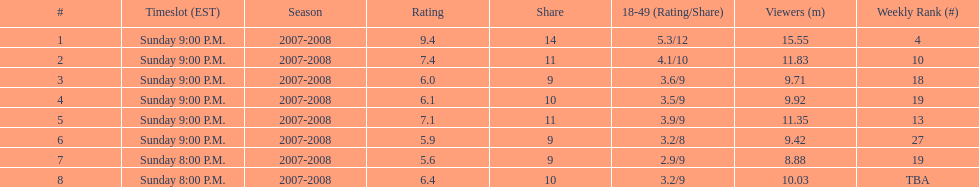Help me parse the entirety of this table. {'header': ['#', 'Timeslot (EST)', 'Season', 'Rating', 'Share', '18-49 (Rating/Share)', 'Viewers (m)', 'Weekly Rank (#)'], 'rows': [['1', 'Sunday 9:00 P.M.', '2007-2008', '9.4', '14', '5.3/12', '15.55', '4'], ['2', 'Sunday 9:00 P.M.', '2007-2008', '7.4', '11', '4.1/10', '11.83', '10'], ['3', 'Sunday 9:00 P.M.', '2007-2008', '6.0', '9', '3.6/9', '9.71', '18'], ['4', 'Sunday 9:00 P.M.', '2007-2008', '6.1', '10', '3.5/9', '9.92', '19'], ['5', 'Sunday 9:00 P.M.', '2007-2008', '7.1', '11', '3.9/9', '11.35', '13'], ['6', 'Sunday 9:00 P.M.', '2007-2008', '5.9', '9', '3.2/8', '9.42', '27'], ['7', 'Sunday 8:00 P.M.', '2007-2008', '5.6', '9', '2.9/9', '8.88', '19'], ['8', 'Sunday 8:00 P.M.', '2007-2008', '6.4', '10', '3.2/9', '10.03', 'TBA']]} What time slot did the show have for its first 6 episodes? Sunday 9:00 P.M. 